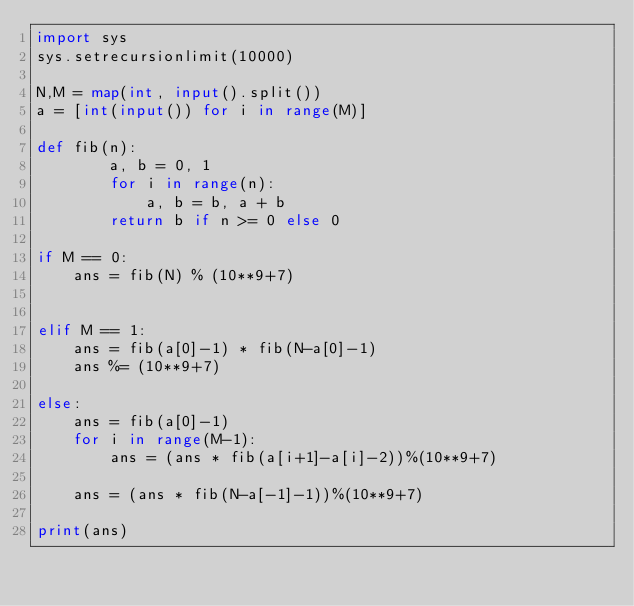Convert code to text. <code><loc_0><loc_0><loc_500><loc_500><_Python_>import sys
sys.setrecursionlimit(10000)

N,M = map(int, input().split())
a = [int(input()) for i in range(M)]

def fib(n):
        a, b = 0, 1
        for i in range(n):
            a, b = b, a + b
        return b if n >= 0 else 0

if M == 0:
    ans = fib(N) % (10**9+7)


elif M == 1:
    ans = fib(a[0]-1) * fib(N-a[0]-1)
    ans %= (10**9+7)

else:
    ans = fib(a[0]-1)
    for i in range(M-1):
        ans = (ans * fib(a[i+1]-a[i]-2))%(10**9+7)

    ans = (ans * fib(N-a[-1]-1))%(10**9+7)

print(ans)</code> 